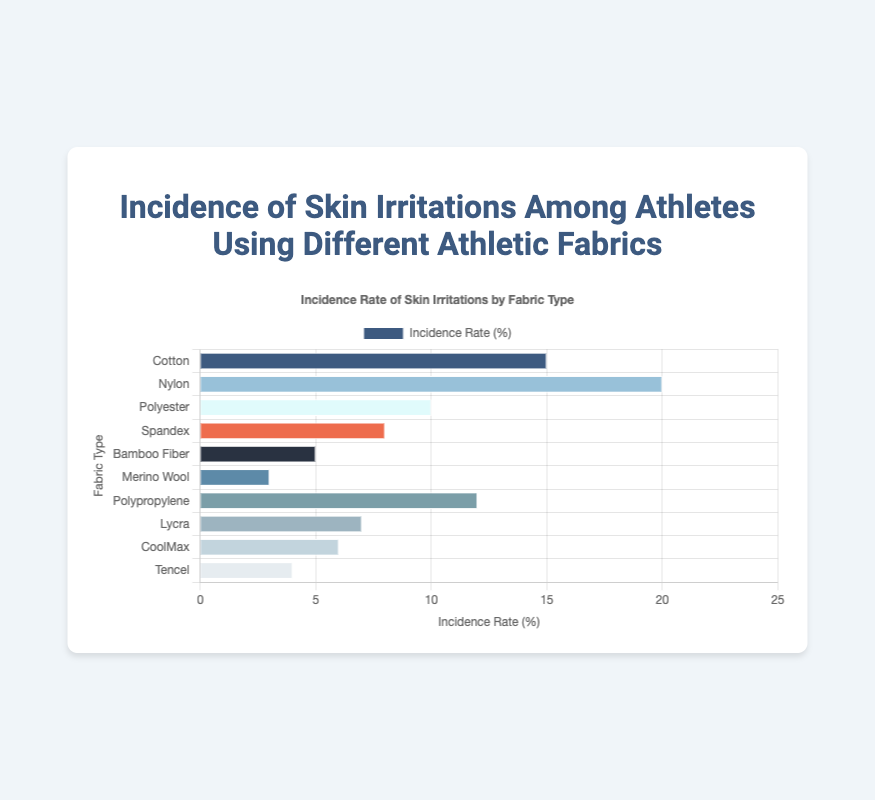Which fabric has the highest incidence rate of skin irritations? The fabric with the highest incidence rate will have the longest bar. Referring to the figure, Nylon has the longest bar.
Answer: Nylon Which fabric has the lowest incidence rate of skin irritations? The fabric with the lowest incidence rate will have the shortest bar. Referring to the figure, Merino Wool has the shortest bar.
Answer: Merino Wool What is the incidence rate of skin irritations for Polyester and Cotton combined? Add the incidence rates for Polyester (10) and Cotton (15). So, 10 + 15 = 25.
Answer: 25 How many fabrics have an incidence rate higher than 10%? Count the bars longer than the 10% mark. The fabrics are Cotton, Nylon, and Polypropylene. Therefore, 3 fabrics.
Answer: 3 Is the incidence rate of CoolMax greater than that of Lycra? Compare the length of the bars for CoolMax and Lycra. The bar for Lycra is longer.
Answer: No Which fabric has an incidence rate exactly in the middle of the dataset? List the incidence rates in ascending order: 3, 4, 5, 6, 7, 8, 10, 12, 15, 20. The middle value (median) of this dataset is (8 + 10)/2 = 9. Polyester has the closest value to 9, which is 10.
Answer: Polyester What is the difference in incidence rates between the fabric with the highest and the fabric with the lowest irritation rates? Subtract the incidence rate of Merino Wool (3%) from Nylon (20%). So, 20 - 3 = 17.
Answer: 17 What is the average incidence rate for all fabrics? Sum all the incidence rates: 15 + 20 + 10 + 8 + 5 + 3 + 12 + 7 + 6 + 4 = 90. Then divide by the number of fabrics, which is 10. So, 90 / 10 = 9.
Answer: 9 Which fabric has a similar incidence rate to Spandex? Look for a fabric with an incidence close to Spandex's rate (8%). Lycra has an incidence rate of 7%, which is closest.
Answer: Lycra Is the combined incidence rate of Bamboo Fiber and Merino Wool greater than that of Nylon? Add the rates of Bamboo Fiber (5%) and Merino Wool (3%). So 5 + 3 = 8. Compare that to Nylon (20%). 8 is less than 20.
Answer: No 